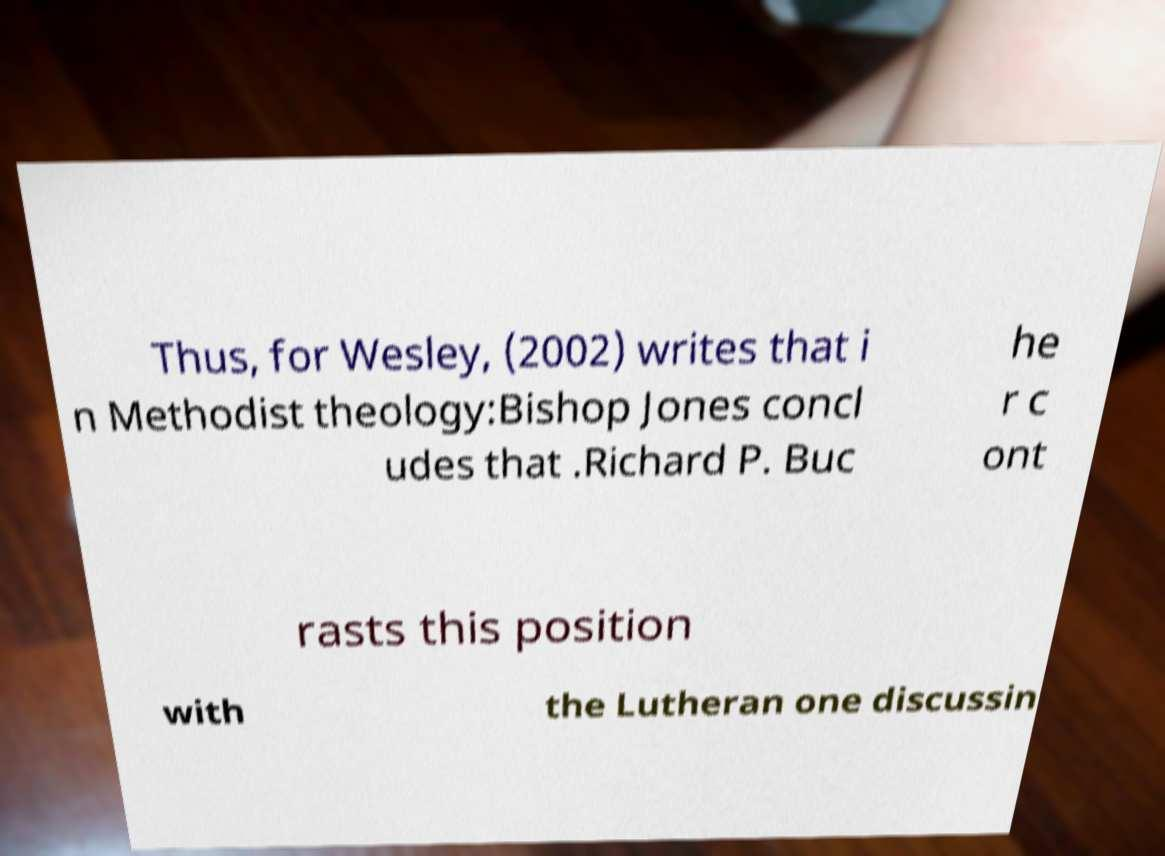Please identify and transcribe the text found in this image. Thus, for Wesley, (2002) writes that i n Methodist theology:Bishop Jones concl udes that .Richard P. Buc he r c ont rasts this position with the Lutheran one discussin 